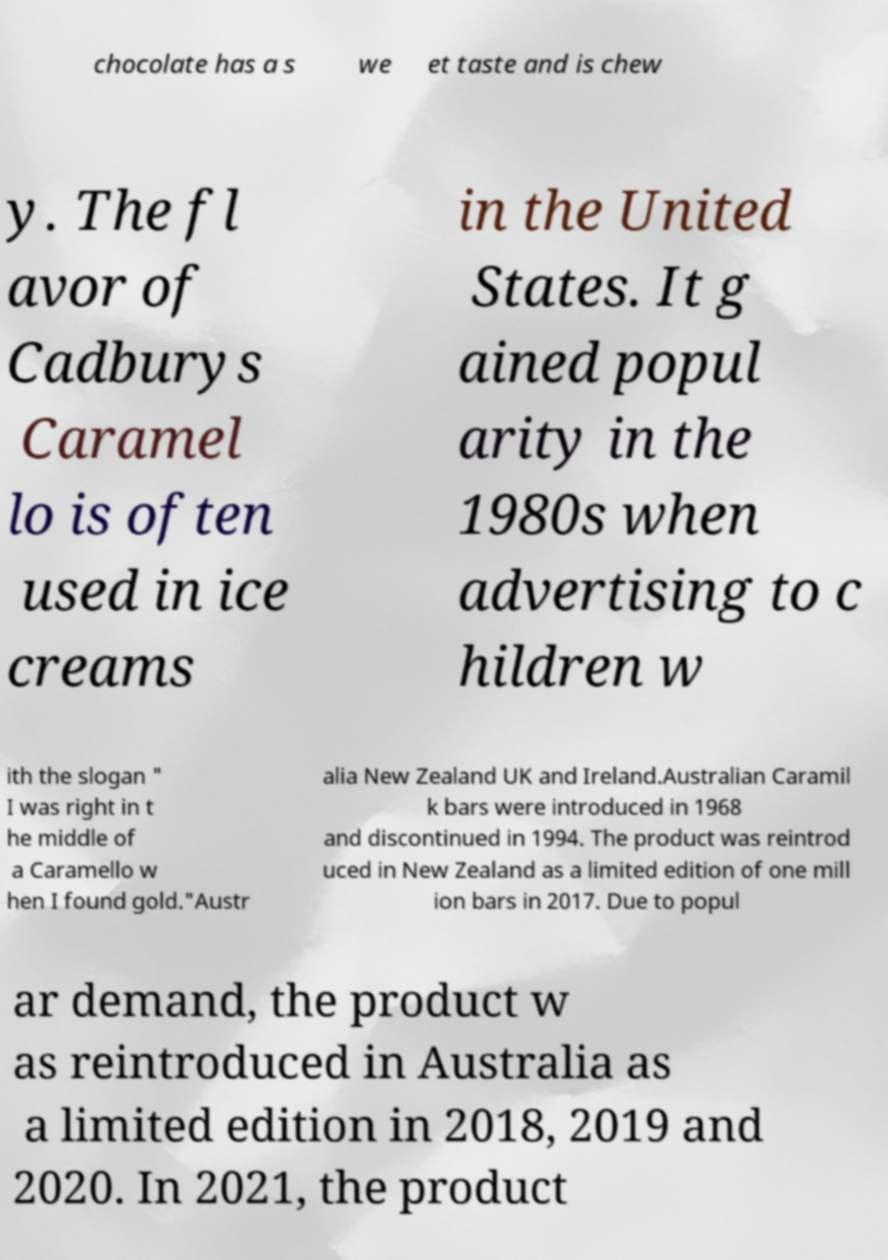Can you accurately transcribe the text from the provided image for me? chocolate has a s we et taste and is chew y. The fl avor of Cadburys Caramel lo is often used in ice creams in the United States. It g ained popul arity in the 1980s when advertising to c hildren w ith the slogan " I was right in t he middle of a Caramello w hen I found gold."Austr alia New Zealand UK and Ireland.Australian Caramil k bars were introduced in 1968 and discontinued in 1994. The product was reintrod uced in New Zealand as a limited edition of one mill ion bars in 2017. Due to popul ar demand, the product w as reintroduced in Australia as a limited edition in 2018, 2019 and 2020. In 2021, the product 